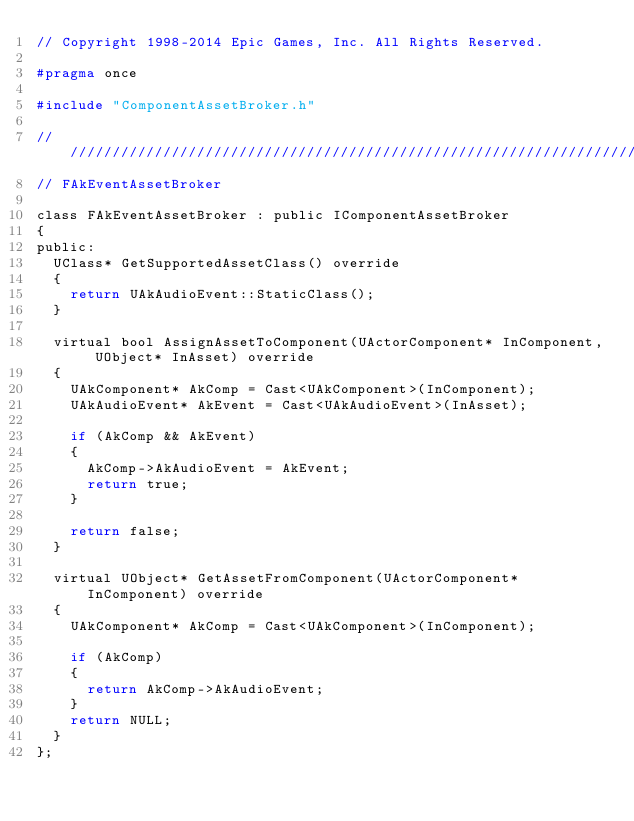Convert code to text. <code><loc_0><loc_0><loc_500><loc_500><_C_>// Copyright 1998-2014 Epic Games, Inc. All Rights Reserved.

#pragma once

#include "ComponentAssetBroker.h"

//////////////////////////////////////////////////////////////////////////
// FAkEventAssetBroker

class FAkEventAssetBroker : public IComponentAssetBroker
{
public:
	UClass* GetSupportedAssetClass() override
	{
		return UAkAudioEvent::StaticClass();
	}

	virtual bool AssignAssetToComponent(UActorComponent* InComponent, UObject* InAsset) override
	{
		UAkComponent* AkComp = Cast<UAkComponent>(InComponent);
		UAkAudioEvent* AkEvent = Cast<UAkAudioEvent>(InAsset);
		
		if (AkComp && AkEvent)
		{
			AkComp->AkAudioEvent = AkEvent;
			return true;
		}

		return false;
	}

	virtual UObject* GetAssetFromComponent(UActorComponent* InComponent) override
	{
		UAkComponent* AkComp = Cast<UAkComponent>(InComponent);
		
		if (AkComp)
		{
			return AkComp->AkAudioEvent;
		}
		return NULL;
	}
};

</code> 